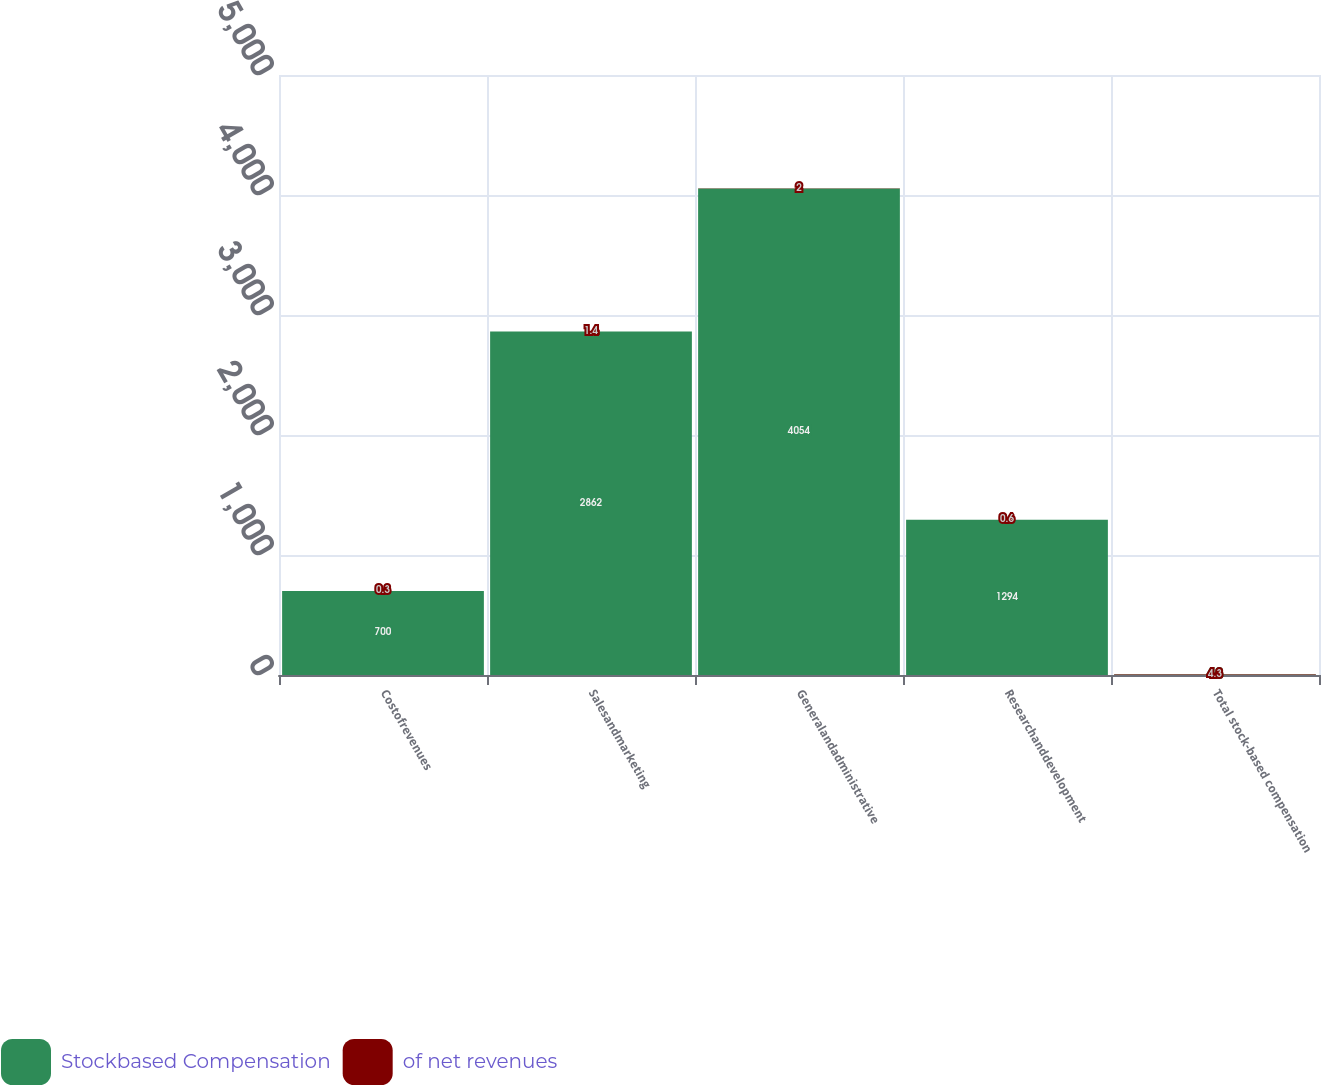Convert chart to OTSL. <chart><loc_0><loc_0><loc_500><loc_500><stacked_bar_chart><ecel><fcel>Costofrevenues<fcel>Salesandmarketing<fcel>Generalandadministrative<fcel>Researchanddevelopment<fcel>Total stock-based compensation<nl><fcel>Stockbased Compensation<fcel>700<fcel>2862<fcel>4054<fcel>1294<fcel>4.3<nl><fcel>of net revenues<fcel>0.3<fcel>1.4<fcel>2<fcel>0.6<fcel>4.3<nl></chart> 